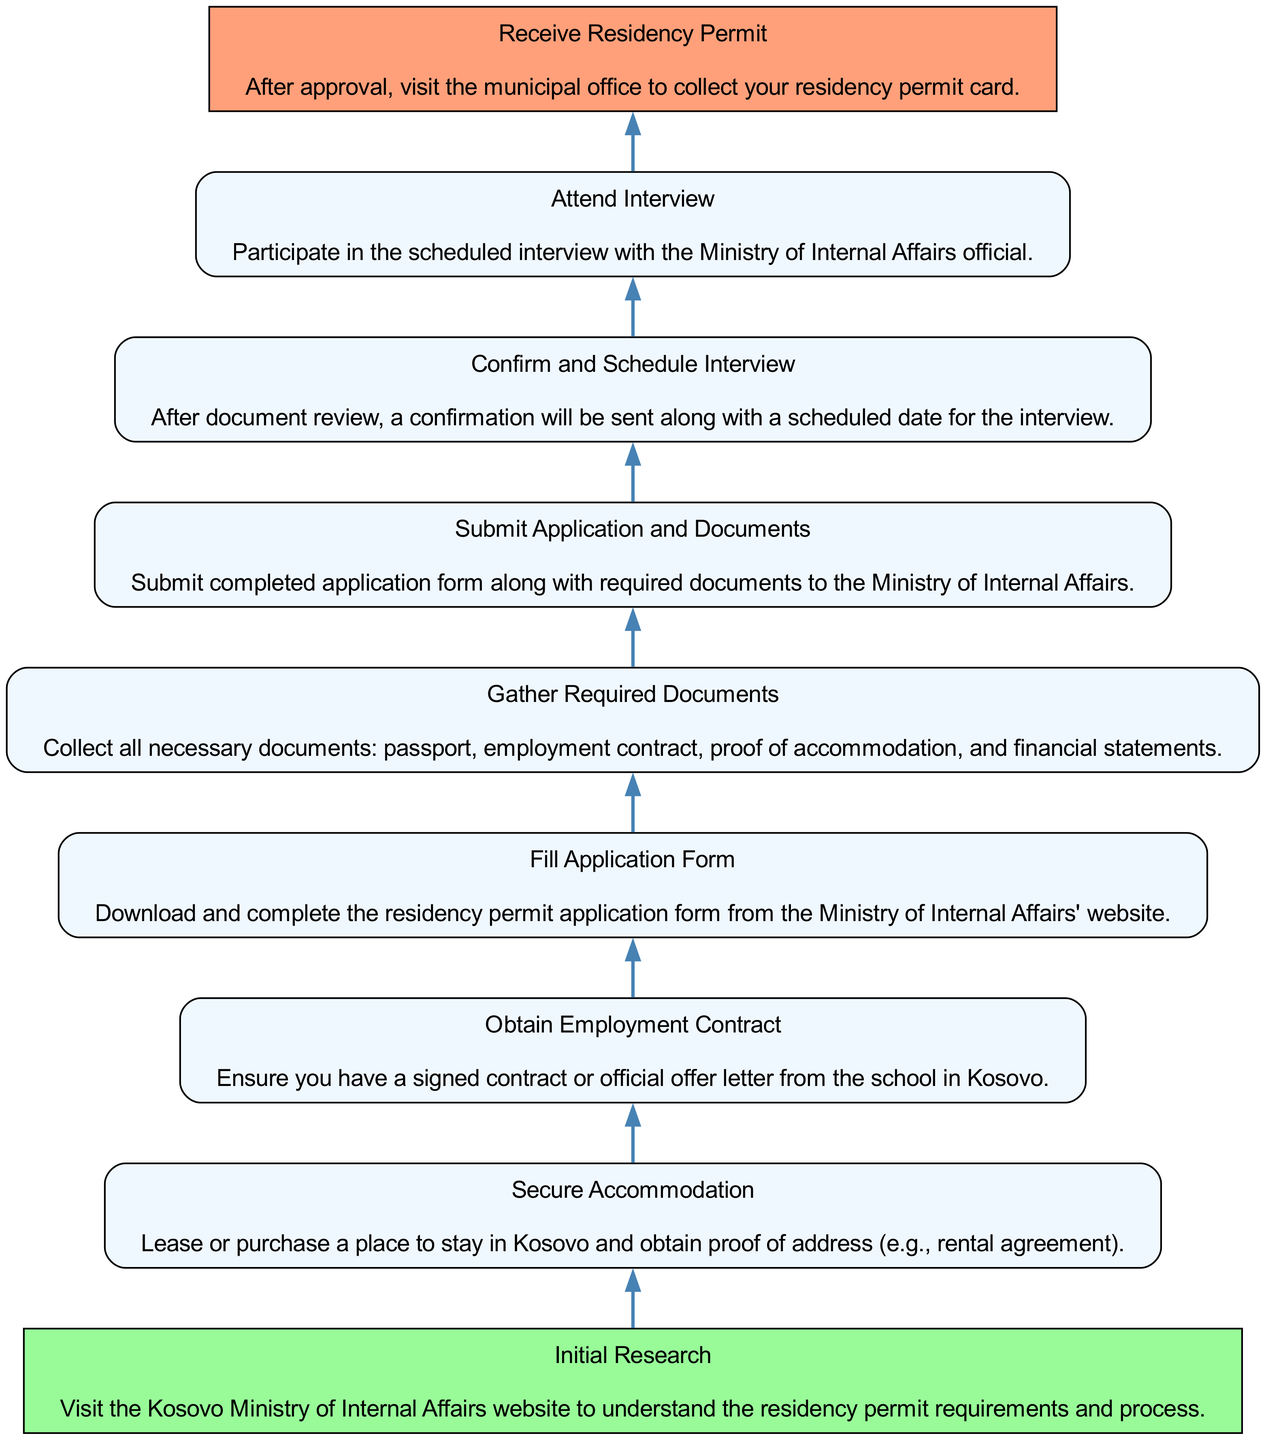What is the first step in the residency permit application process? The first step in the diagram, as represented at the bottom, is "Initial Research," which begins the flow of the application process.
Answer: Initial Research How many total steps are there in the application process? By counting the steps listed in the diagram, we can see that there are a total of 9 steps from "Initial Research" to "Receive Residency Permit."
Answer: 9 What step comes before "Attend Interview"? The step immediately preceding "Attend Interview" in the flow is "Confirm and Schedule Interview," showing the order of actions leading to the interview.
Answer: Confirm and Schedule Interview What is required to be collected before submitting the application? According to the diagram, the step titled "Gather Required Documents" specifies that necessary documents need to be collected before the application can be submitted.
Answer: Gather Required Documents Which step concludes the residency permit application process? The final step at the top of the diagram is "Receive Residency Permit," indicating that this is where the process ends after all prior steps have been completed.
Answer: Receive Residency Permit Which step requires proof of address? The diagram states that "Secure Accommodation" is the step where proof of address must be obtained, indicating it is essential for the application process.
Answer: Secure Accommodation What document is necessary after filling the application form? According to the flow chart, after the step "Fill Application Form," the next step is to "Submit Application and Documents," signifying that the completed form must be submitted along with the documents.
Answer: Submit Application and Documents Which step mentions obtaining an employment contract? The step labeled "Obtain Employment Contract" directly indicates the requirement of having a signed contract or official offer letter from a school in Kosovo.
Answer: Obtain Employment Contract What action follows "Submit Application and Documents"? Following the submission of the application and documents, the next action in the flow is to "Attend Interview," indicating a progression in the residency permit application.
Answer: Attend Interview 